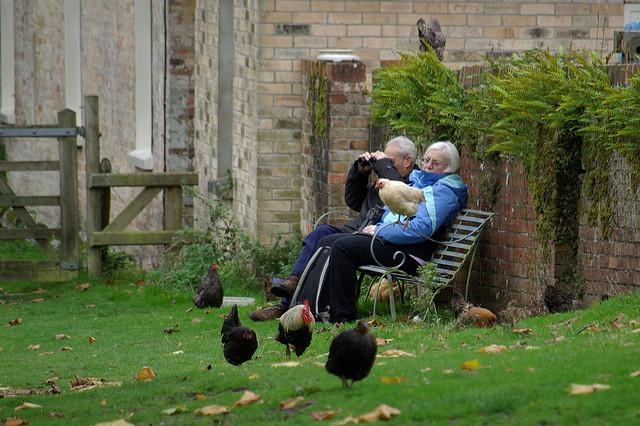What is the freshest food available to this woman?

Choices:
A) flour
B) chips
C) eggs
D) ice cream eggs 